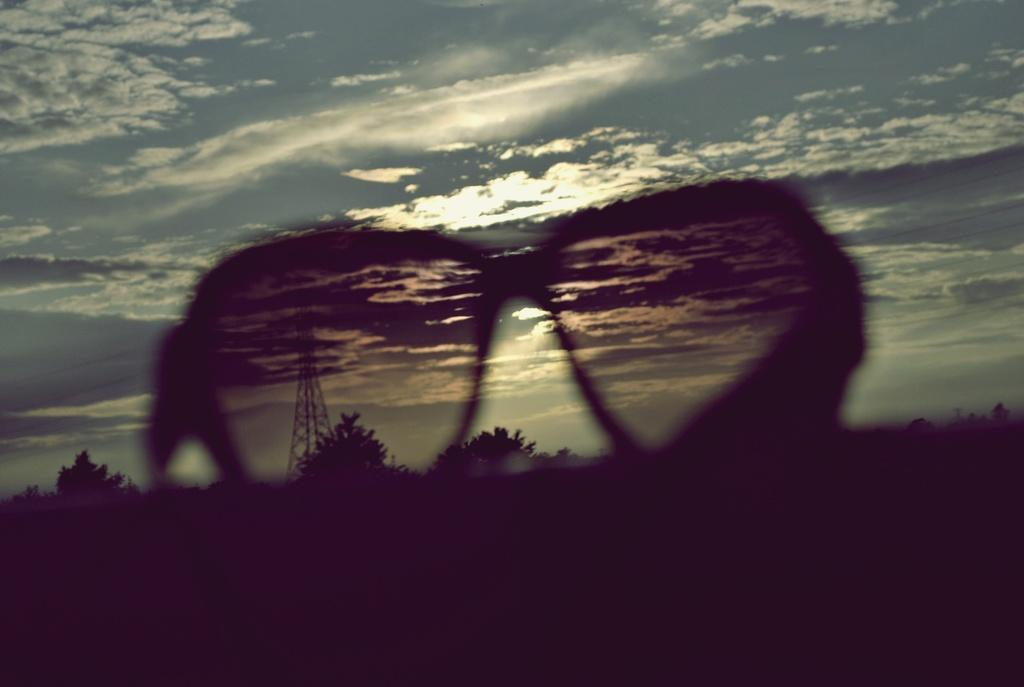What object can be seen in the image? There are spectacles in the image. What can be seen in the background of the image? There is a tower, trees, and clouds in the background of the image. What type of fruit is hanging from the trees in the image? There is no fruit visible in the image; only trees, a tower, and clouds can be seen in the background. 